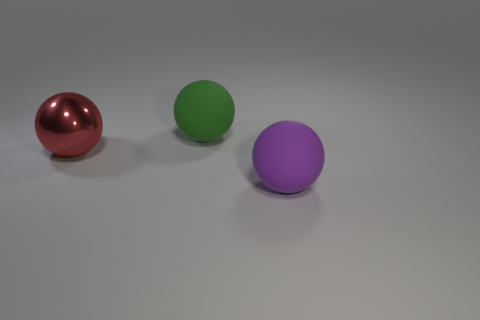What is the material of the red object that is the same size as the purple ball?
Provide a short and direct response. Metal. Is there another green ball of the same size as the shiny sphere?
Provide a short and direct response. Yes. Are there fewer big rubber things in front of the big purple object than big yellow rubber objects?
Ensure brevity in your answer.  No. Are there fewer large red things that are to the right of the red metal object than big rubber spheres that are to the right of the big green rubber ball?
Keep it short and to the point. Yes. What number of cylinders are either tiny yellow matte things or large purple objects?
Your answer should be compact. 0. Do the ball that is in front of the large red metal ball and the large green object that is behind the large purple rubber sphere have the same material?
Provide a short and direct response. Yes. What shape is the green rubber object that is the same size as the purple rubber object?
Keep it short and to the point. Sphere. What number of yellow things are large metal spheres or big rubber balls?
Ensure brevity in your answer.  0. What number of other things are the same material as the big green sphere?
Ensure brevity in your answer.  1. Is there a big thing that is in front of the rubber ball that is behind the large matte sphere that is in front of the green sphere?
Provide a short and direct response. Yes. 